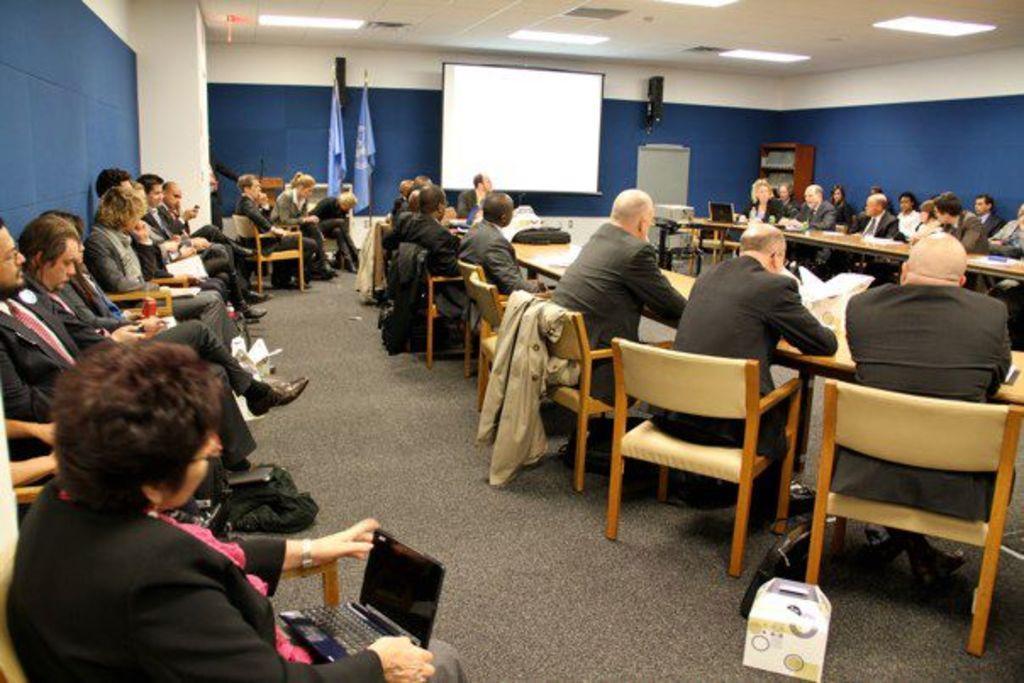In one or two sentences, can you explain what this image depicts? In this picture I can see some people are sitting on the chairs and holding laptops, in front there is a table on which I can see few objects are placed and also there is a white color board in front off the wall, I can see lights to the roof. 